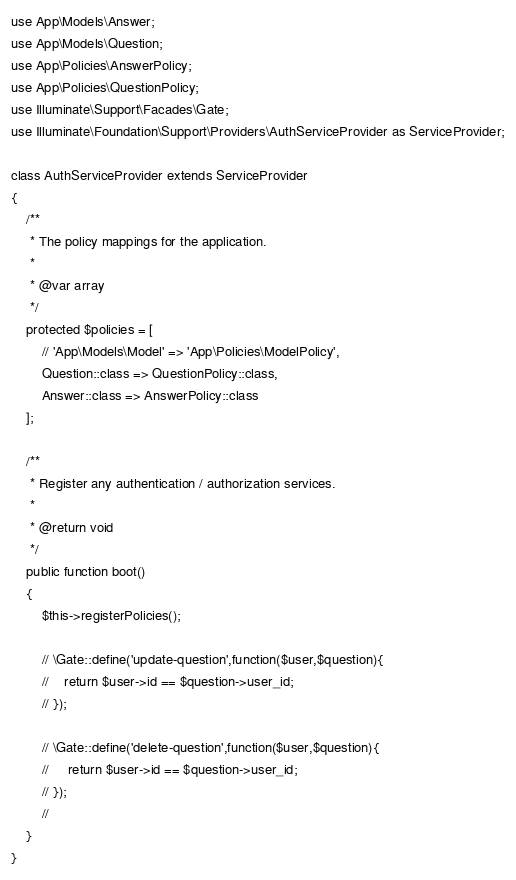Convert code to text. <code><loc_0><loc_0><loc_500><loc_500><_PHP_>use App\Models\Answer;
use App\Models\Question;
use App\Policies\AnswerPolicy;
use App\Policies\QuestionPolicy;
use Illuminate\Support\Facades\Gate;
use Illuminate\Foundation\Support\Providers\AuthServiceProvider as ServiceProvider;

class AuthServiceProvider extends ServiceProvider
{
    /**
     * The policy mappings for the application.
     *
     * @var array
     */
    protected $policies = [
        // 'App\Models\Model' => 'App\Policies\ModelPolicy',
        Question::class => QuestionPolicy::class,
        Answer::class => AnswerPolicy::class
    ];

    /**
     * Register any authentication / authorization services.
     *
     * @return void
     */
    public function boot()
    {
        $this->registerPolicies();

        // \Gate::define('update-question',function($user,$question){
        //    return $user->id == $question->user_id;
        // });

        // \Gate::define('delete-question',function($user,$question){
        //     return $user->id == $question->user_id;
        // });
        //
    }
}
</code> 